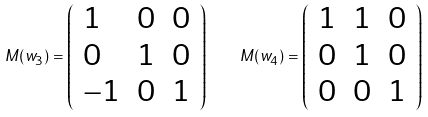<formula> <loc_0><loc_0><loc_500><loc_500>M ( w _ { 3 } ) = \left ( \begin{array} { l l l } 1 & 0 & 0 \\ 0 & 1 & 0 \\ - 1 & 0 & 1 \end{array} \right ) \quad M ( w _ { 4 } ) = \left ( \begin{array} { l l l } 1 & 1 & 0 \\ 0 & 1 & 0 \\ 0 & 0 & 1 \end{array} \right )</formula> 